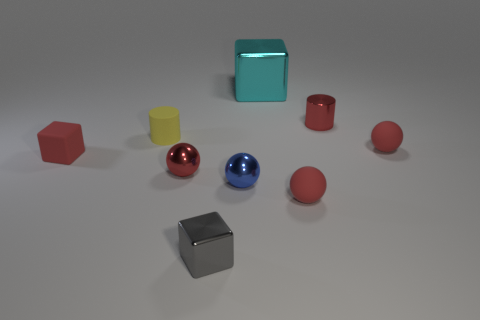Are there any other things that are the same size as the cyan shiny object?
Provide a succinct answer. No. Does the red thing that is on the left side of the yellow cylinder have the same material as the cyan thing?
Give a very brief answer. No. What is the shape of the small red metal thing to the right of the large metallic cube?
Your answer should be compact. Cylinder. There is a yellow object that is the same size as the red cube; what is it made of?
Give a very brief answer. Rubber. What number of things are tiny yellow matte things that are in front of the big cyan block or tiny spheres that are behind the blue shiny ball?
Your answer should be very brief. 3. There is a yellow cylinder that is made of the same material as the tiny red block; what size is it?
Your answer should be very brief. Small. How many metallic objects are either red spheres or large objects?
Your answer should be very brief. 2. How big is the cyan metal block?
Give a very brief answer. Large. Do the gray shiny cube and the red metal ball have the same size?
Your answer should be very brief. Yes. What is the tiny yellow cylinder left of the big shiny thing made of?
Give a very brief answer. Rubber. 